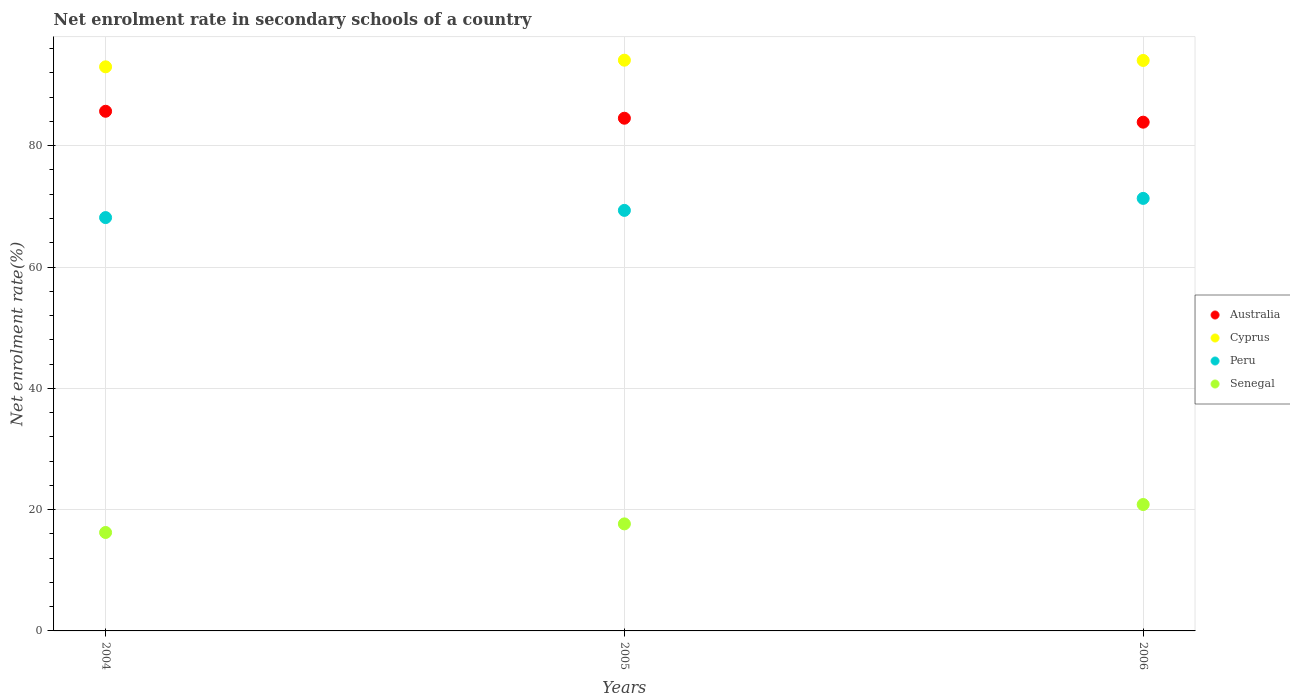How many different coloured dotlines are there?
Your answer should be compact. 4. What is the net enrolment rate in secondary schools in Peru in 2005?
Offer a very short reply. 69.34. Across all years, what is the maximum net enrolment rate in secondary schools in Australia?
Your answer should be compact. 85.68. Across all years, what is the minimum net enrolment rate in secondary schools in Peru?
Keep it short and to the point. 68.15. In which year was the net enrolment rate in secondary schools in Cyprus maximum?
Your answer should be compact. 2005. In which year was the net enrolment rate in secondary schools in Senegal minimum?
Offer a terse response. 2004. What is the total net enrolment rate in secondary schools in Australia in the graph?
Offer a very short reply. 254.1. What is the difference between the net enrolment rate in secondary schools in Senegal in 2004 and that in 2005?
Your answer should be very brief. -1.42. What is the difference between the net enrolment rate in secondary schools in Australia in 2004 and the net enrolment rate in secondary schools in Cyprus in 2005?
Ensure brevity in your answer.  -8.42. What is the average net enrolment rate in secondary schools in Australia per year?
Your response must be concise. 84.7. In the year 2004, what is the difference between the net enrolment rate in secondary schools in Cyprus and net enrolment rate in secondary schools in Senegal?
Give a very brief answer. 76.78. What is the ratio of the net enrolment rate in secondary schools in Australia in 2004 to that in 2006?
Your answer should be compact. 1.02. What is the difference between the highest and the second highest net enrolment rate in secondary schools in Peru?
Your answer should be very brief. 1.98. What is the difference between the highest and the lowest net enrolment rate in secondary schools in Senegal?
Give a very brief answer. 4.61. Is it the case that in every year, the sum of the net enrolment rate in secondary schools in Australia and net enrolment rate in secondary schools in Peru  is greater than the sum of net enrolment rate in secondary schools in Senegal and net enrolment rate in secondary schools in Cyprus?
Your response must be concise. Yes. Is the net enrolment rate in secondary schools in Peru strictly greater than the net enrolment rate in secondary schools in Senegal over the years?
Offer a very short reply. Yes. How many dotlines are there?
Your response must be concise. 4. How many years are there in the graph?
Offer a very short reply. 3. Are the values on the major ticks of Y-axis written in scientific E-notation?
Ensure brevity in your answer.  No. Does the graph contain any zero values?
Your answer should be very brief. No. What is the title of the graph?
Offer a very short reply. Net enrolment rate in secondary schools of a country. What is the label or title of the Y-axis?
Ensure brevity in your answer.  Net enrolment rate(%). What is the Net enrolment rate(%) of Australia in 2004?
Provide a short and direct response. 85.68. What is the Net enrolment rate(%) in Cyprus in 2004?
Provide a succinct answer. 93.01. What is the Net enrolment rate(%) in Peru in 2004?
Make the answer very short. 68.15. What is the Net enrolment rate(%) in Senegal in 2004?
Your answer should be very brief. 16.23. What is the Net enrolment rate(%) of Australia in 2005?
Give a very brief answer. 84.53. What is the Net enrolment rate(%) in Cyprus in 2005?
Your answer should be compact. 94.1. What is the Net enrolment rate(%) in Peru in 2005?
Ensure brevity in your answer.  69.34. What is the Net enrolment rate(%) of Senegal in 2005?
Provide a succinct answer. 17.65. What is the Net enrolment rate(%) in Australia in 2006?
Offer a terse response. 83.88. What is the Net enrolment rate(%) of Cyprus in 2006?
Ensure brevity in your answer.  94.06. What is the Net enrolment rate(%) in Peru in 2006?
Provide a short and direct response. 71.32. What is the Net enrolment rate(%) of Senegal in 2006?
Provide a short and direct response. 20.84. Across all years, what is the maximum Net enrolment rate(%) of Australia?
Offer a very short reply. 85.68. Across all years, what is the maximum Net enrolment rate(%) of Cyprus?
Your answer should be compact. 94.1. Across all years, what is the maximum Net enrolment rate(%) of Peru?
Your answer should be very brief. 71.32. Across all years, what is the maximum Net enrolment rate(%) of Senegal?
Your response must be concise. 20.84. Across all years, what is the minimum Net enrolment rate(%) in Australia?
Keep it short and to the point. 83.88. Across all years, what is the minimum Net enrolment rate(%) in Cyprus?
Provide a succinct answer. 93.01. Across all years, what is the minimum Net enrolment rate(%) of Peru?
Your response must be concise. 68.15. Across all years, what is the minimum Net enrolment rate(%) in Senegal?
Provide a succinct answer. 16.23. What is the total Net enrolment rate(%) in Australia in the graph?
Make the answer very short. 254.1. What is the total Net enrolment rate(%) in Cyprus in the graph?
Keep it short and to the point. 281.17. What is the total Net enrolment rate(%) in Peru in the graph?
Provide a succinct answer. 208.8. What is the total Net enrolment rate(%) of Senegal in the graph?
Your answer should be compact. 54.72. What is the difference between the Net enrolment rate(%) in Australia in 2004 and that in 2005?
Provide a short and direct response. 1.15. What is the difference between the Net enrolment rate(%) in Cyprus in 2004 and that in 2005?
Offer a terse response. -1.09. What is the difference between the Net enrolment rate(%) in Peru in 2004 and that in 2005?
Make the answer very short. -1.19. What is the difference between the Net enrolment rate(%) of Senegal in 2004 and that in 2005?
Offer a terse response. -1.42. What is the difference between the Net enrolment rate(%) in Australia in 2004 and that in 2006?
Offer a very short reply. 1.8. What is the difference between the Net enrolment rate(%) in Cyprus in 2004 and that in 2006?
Your answer should be very brief. -1.05. What is the difference between the Net enrolment rate(%) of Peru in 2004 and that in 2006?
Offer a terse response. -3.17. What is the difference between the Net enrolment rate(%) of Senegal in 2004 and that in 2006?
Give a very brief answer. -4.61. What is the difference between the Net enrolment rate(%) of Australia in 2005 and that in 2006?
Your answer should be very brief. 0.65. What is the difference between the Net enrolment rate(%) in Cyprus in 2005 and that in 2006?
Ensure brevity in your answer.  0.04. What is the difference between the Net enrolment rate(%) in Peru in 2005 and that in 2006?
Ensure brevity in your answer.  -1.98. What is the difference between the Net enrolment rate(%) in Senegal in 2005 and that in 2006?
Your answer should be compact. -3.19. What is the difference between the Net enrolment rate(%) of Australia in 2004 and the Net enrolment rate(%) of Cyprus in 2005?
Provide a succinct answer. -8.42. What is the difference between the Net enrolment rate(%) of Australia in 2004 and the Net enrolment rate(%) of Peru in 2005?
Keep it short and to the point. 16.34. What is the difference between the Net enrolment rate(%) in Australia in 2004 and the Net enrolment rate(%) in Senegal in 2005?
Your answer should be very brief. 68.03. What is the difference between the Net enrolment rate(%) in Cyprus in 2004 and the Net enrolment rate(%) in Peru in 2005?
Ensure brevity in your answer.  23.67. What is the difference between the Net enrolment rate(%) in Cyprus in 2004 and the Net enrolment rate(%) in Senegal in 2005?
Keep it short and to the point. 75.36. What is the difference between the Net enrolment rate(%) in Peru in 2004 and the Net enrolment rate(%) in Senegal in 2005?
Ensure brevity in your answer.  50.5. What is the difference between the Net enrolment rate(%) in Australia in 2004 and the Net enrolment rate(%) in Cyprus in 2006?
Keep it short and to the point. -8.38. What is the difference between the Net enrolment rate(%) in Australia in 2004 and the Net enrolment rate(%) in Peru in 2006?
Offer a very short reply. 14.37. What is the difference between the Net enrolment rate(%) of Australia in 2004 and the Net enrolment rate(%) of Senegal in 2006?
Your response must be concise. 64.84. What is the difference between the Net enrolment rate(%) in Cyprus in 2004 and the Net enrolment rate(%) in Peru in 2006?
Keep it short and to the point. 21.69. What is the difference between the Net enrolment rate(%) in Cyprus in 2004 and the Net enrolment rate(%) in Senegal in 2006?
Provide a short and direct response. 72.17. What is the difference between the Net enrolment rate(%) in Peru in 2004 and the Net enrolment rate(%) in Senegal in 2006?
Your answer should be compact. 47.31. What is the difference between the Net enrolment rate(%) in Australia in 2005 and the Net enrolment rate(%) in Cyprus in 2006?
Ensure brevity in your answer.  -9.53. What is the difference between the Net enrolment rate(%) of Australia in 2005 and the Net enrolment rate(%) of Peru in 2006?
Give a very brief answer. 13.22. What is the difference between the Net enrolment rate(%) in Australia in 2005 and the Net enrolment rate(%) in Senegal in 2006?
Provide a succinct answer. 63.69. What is the difference between the Net enrolment rate(%) in Cyprus in 2005 and the Net enrolment rate(%) in Peru in 2006?
Give a very brief answer. 22.79. What is the difference between the Net enrolment rate(%) in Cyprus in 2005 and the Net enrolment rate(%) in Senegal in 2006?
Your answer should be compact. 73.26. What is the difference between the Net enrolment rate(%) in Peru in 2005 and the Net enrolment rate(%) in Senegal in 2006?
Your answer should be compact. 48.5. What is the average Net enrolment rate(%) in Australia per year?
Your answer should be very brief. 84.7. What is the average Net enrolment rate(%) of Cyprus per year?
Your answer should be very brief. 93.72. What is the average Net enrolment rate(%) of Peru per year?
Give a very brief answer. 69.6. What is the average Net enrolment rate(%) in Senegal per year?
Give a very brief answer. 18.24. In the year 2004, what is the difference between the Net enrolment rate(%) of Australia and Net enrolment rate(%) of Cyprus?
Your response must be concise. -7.33. In the year 2004, what is the difference between the Net enrolment rate(%) in Australia and Net enrolment rate(%) in Peru?
Provide a short and direct response. 17.53. In the year 2004, what is the difference between the Net enrolment rate(%) in Australia and Net enrolment rate(%) in Senegal?
Your answer should be very brief. 69.45. In the year 2004, what is the difference between the Net enrolment rate(%) in Cyprus and Net enrolment rate(%) in Peru?
Offer a terse response. 24.86. In the year 2004, what is the difference between the Net enrolment rate(%) in Cyprus and Net enrolment rate(%) in Senegal?
Provide a short and direct response. 76.78. In the year 2004, what is the difference between the Net enrolment rate(%) in Peru and Net enrolment rate(%) in Senegal?
Provide a short and direct response. 51.92. In the year 2005, what is the difference between the Net enrolment rate(%) of Australia and Net enrolment rate(%) of Cyprus?
Ensure brevity in your answer.  -9.57. In the year 2005, what is the difference between the Net enrolment rate(%) of Australia and Net enrolment rate(%) of Peru?
Ensure brevity in your answer.  15.2. In the year 2005, what is the difference between the Net enrolment rate(%) of Australia and Net enrolment rate(%) of Senegal?
Your answer should be very brief. 66.89. In the year 2005, what is the difference between the Net enrolment rate(%) in Cyprus and Net enrolment rate(%) in Peru?
Offer a terse response. 24.76. In the year 2005, what is the difference between the Net enrolment rate(%) in Cyprus and Net enrolment rate(%) in Senegal?
Your answer should be compact. 76.45. In the year 2005, what is the difference between the Net enrolment rate(%) in Peru and Net enrolment rate(%) in Senegal?
Make the answer very short. 51.69. In the year 2006, what is the difference between the Net enrolment rate(%) of Australia and Net enrolment rate(%) of Cyprus?
Make the answer very short. -10.18. In the year 2006, what is the difference between the Net enrolment rate(%) of Australia and Net enrolment rate(%) of Peru?
Provide a short and direct response. 12.57. In the year 2006, what is the difference between the Net enrolment rate(%) of Australia and Net enrolment rate(%) of Senegal?
Make the answer very short. 63.04. In the year 2006, what is the difference between the Net enrolment rate(%) of Cyprus and Net enrolment rate(%) of Peru?
Offer a terse response. 22.74. In the year 2006, what is the difference between the Net enrolment rate(%) in Cyprus and Net enrolment rate(%) in Senegal?
Make the answer very short. 73.22. In the year 2006, what is the difference between the Net enrolment rate(%) in Peru and Net enrolment rate(%) in Senegal?
Make the answer very short. 50.47. What is the ratio of the Net enrolment rate(%) in Australia in 2004 to that in 2005?
Your answer should be compact. 1.01. What is the ratio of the Net enrolment rate(%) in Cyprus in 2004 to that in 2005?
Keep it short and to the point. 0.99. What is the ratio of the Net enrolment rate(%) in Peru in 2004 to that in 2005?
Your answer should be very brief. 0.98. What is the ratio of the Net enrolment rate(%) in Senegal in 2004 to that in 2005?
Provide a succinct answer. 0.92. What is the ratio of the Net enrolment rate(%) of Australia in 2004 to that in 2006?
Offer a terse response. 1.02. What is the ratio of the Net enrolment rate(%) in Peru in 2004 to that in 2006?
Offer a very short reply. 0.96. What is the ratio of the Net enrolment rate(%) in Senegal in 2004 to that in 2006?
Ensure brevity in your answer.  0.78. What is the ratio of the Net enrolment rate(%) of Cyprus in 2005 to that in 2006?
Your response must be concise. 1. What is the ratio of the Net enrolment rate(%) in Peru in 2005 to that in 2006?
Your answer should be compact. 0.97. What is the ratio of the Net enrolment rate(%) of Senegal in 2005 to that in 2006?
Offer a terse response. 0.85. What is the difference between the highest and the second highest Net enrolment rate(%) in Australia?
Ensure brevity in your answer.  1.15. What is the difference between the highest and the second highest Net enrolment rate(%) of Cyprus?
Your response must be concise. 0.04. What is the difference between the highest and the second highest Net enrolment rate(%) of Peru?
Keep it short and to the point. 1.98. What is the difference between the highest and the second highest Net enrolment rate(%) of Senegal?
Keep it short and to the point. 3.19. What is the difference between the highest and the lowest Net enrolment rate(%) of Australia?
Keep it short and to the point. 1.8. What is the difference between the highest and the lowest Net enrolment rate(%) in Cyprus?
Offer a terse response. 1.09. What is the difference between the highest and the lowest Net enrolment rate(%) of Peru?
Provide a succinct answer. 3.17. What is the difference between the highest and the lowest Net enrolment rate(%) of Senegal?
Provide a succinct answer. 4.61. 